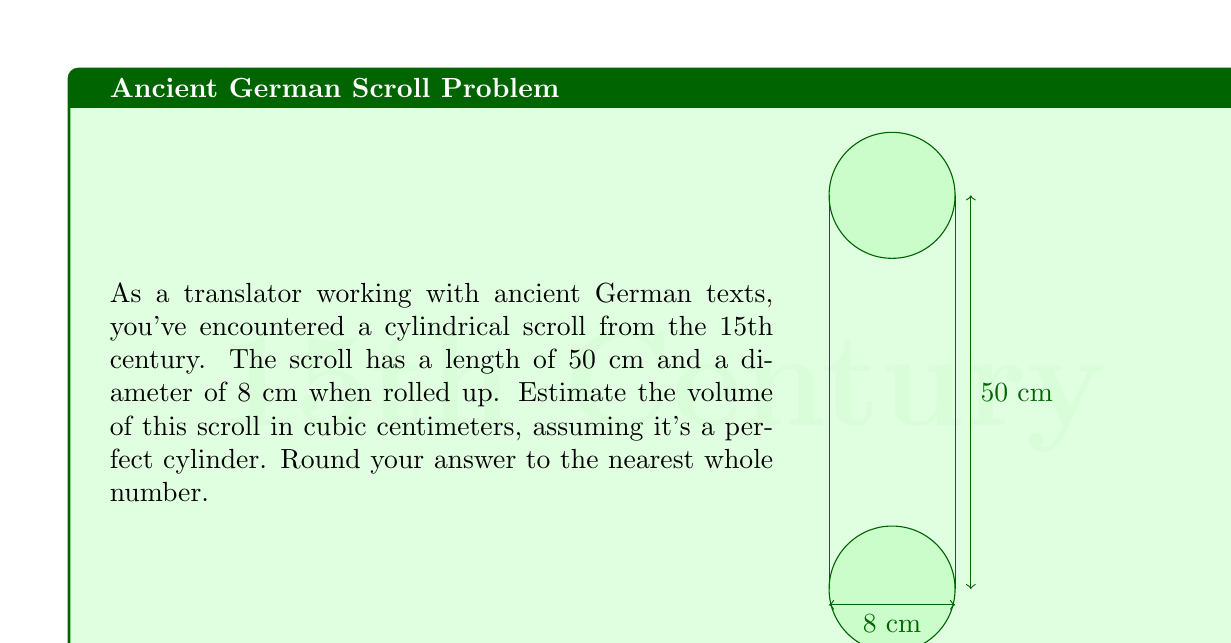Solve this math problem. To estimate the volume of the cylindrical scroll, we'll use the formula for the volume of a cylinder:

$$V = \pi r^2 h$$

Where:
$V$ = volume
$r$ = radius of the base
$h$ = height (length) of the cylinder

1. First, we need to determine the radius. The diameter is given as 8 cm, so the radius is half of that:
   $r = 8 \text{ cm} \div 2 = 4 \text{ cm}$

2. We're given the length (height) of the cylinder as 50 cm:
   $h = 50 \text{ cm}$

3. Now we can substitute these values into our formula:
   $$V = \pi (4 \text{ cm})^2 (50 \text{ cm})$$

4. Simplify:
   $$V = \pi (16 \text{ cm}^2) (50 \text{ cm})$$
   $$V = 800\pi \text{ cm}^3$$

5. Calculate and round to the nearest whole number:
   $$V \approx 2513 \text{ cm}^3$$
Answer: 2513 cm³ 